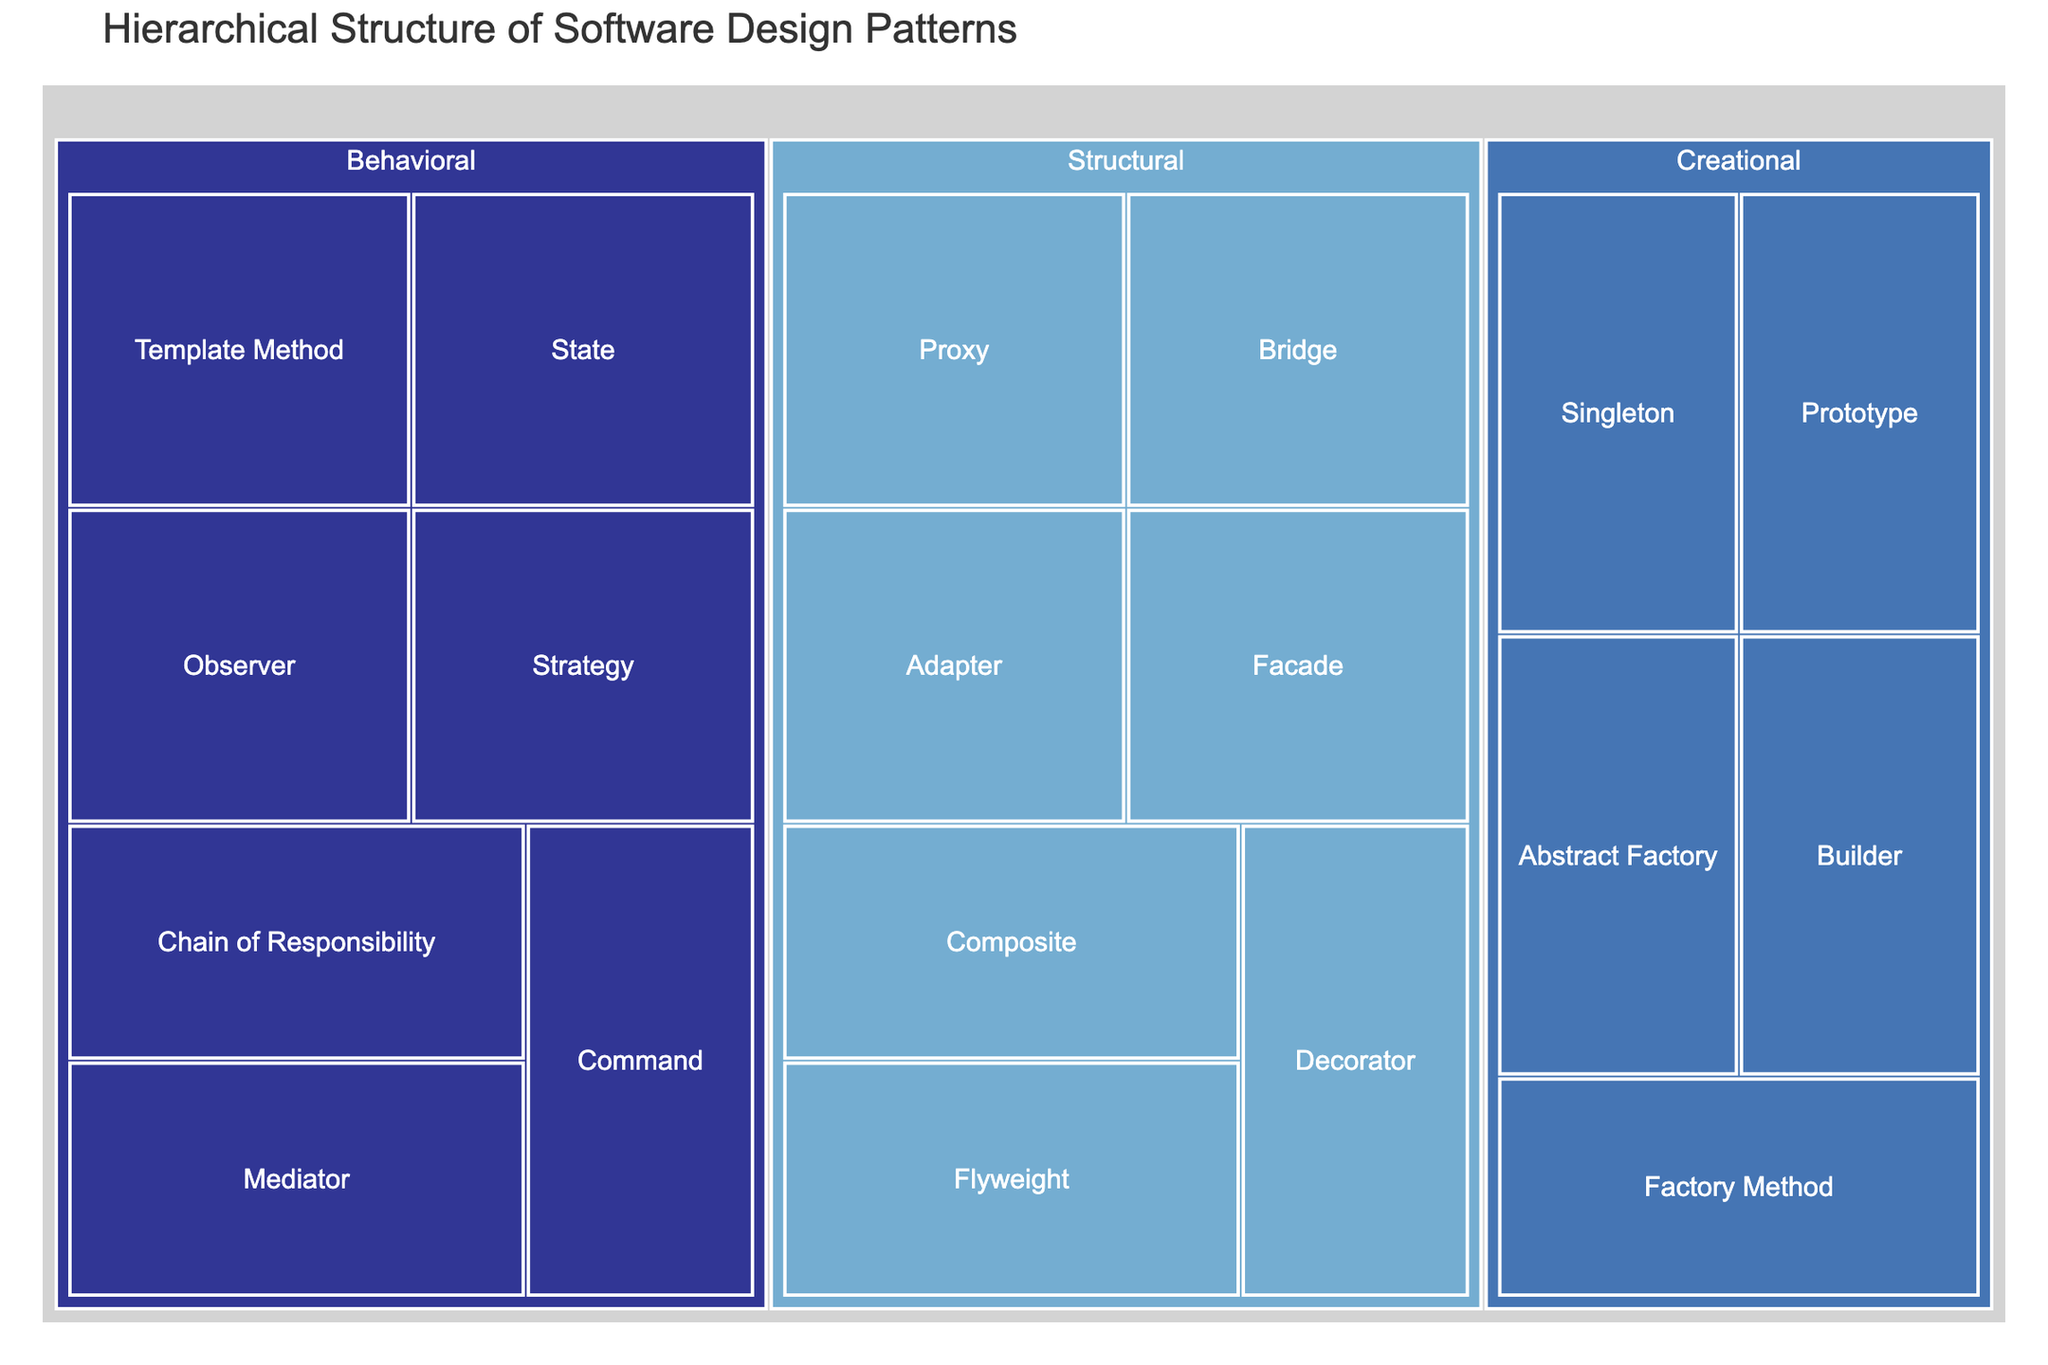How many main categories are presented in the treemap? The treemap shows the hierarchical structure by categorizing software design patterns. To determine the number of main categories, we look at the top-level nodes. These are usually larger and labeled prominently. Identifying the distinct top-level labels in the treemap will give the number of main categories.
Answer: 3 Name one of the creational patterns shown in the treemap. Creational patterns are a subset of software design patterns. By inspecting the nodes under the 'Creational' category, identifying any of them will provide an example.
Answer: Singleton Which category has the most design patterns listed? To determine this, look at each main category (Creational, Structural, and Behavioral) and count the number of design patterns under each category. The category with the highest count will have the most design patterns listed.
Answer: Behavioral Which pattern is categorized under Structural but not Composite? To answer this, examine the list of patterns under the Structural category that are not labeled as 'Composite'. Each label under 'Structural' must be reviewed to identify the ones that don't match 'Composite'.
Answer: Adapter Compare the number of patterns in the Creational and Behavioral categories. Which is more, and by how much? First, count the number of design patterns under each category. For Creational, count Singleton, Factory Method, Abstract Factory, Builder, and Prototype. For Behavioral, count Observer, Strategy, Command, State, Chain of Responsibility, Mediator, and Template Method. Subtract the smaller count from the larger to find the difference.
Answer: Behavioral by 2 What are the top-level categories and their respective colors? Each top-level category in the treemap is visually represented by distinct colors. Identify the colors associated with 'Creational', 'Structural', and 'Behavioral'.
Answer: Varies depending on color scale Which category contains both the Bridge and Proxy design patterns? Look for the design patterns labeled 'Bridge' and 'Proxy'. Check the parent node (category) they are both nested under.
Answer: Structural Is the Chain of Responsibility pattern a Behavioral pattern? Locate the 'Chain of Responsibility' pattern in the treemap and check its parent node to verify the category.
Answer: Yes 